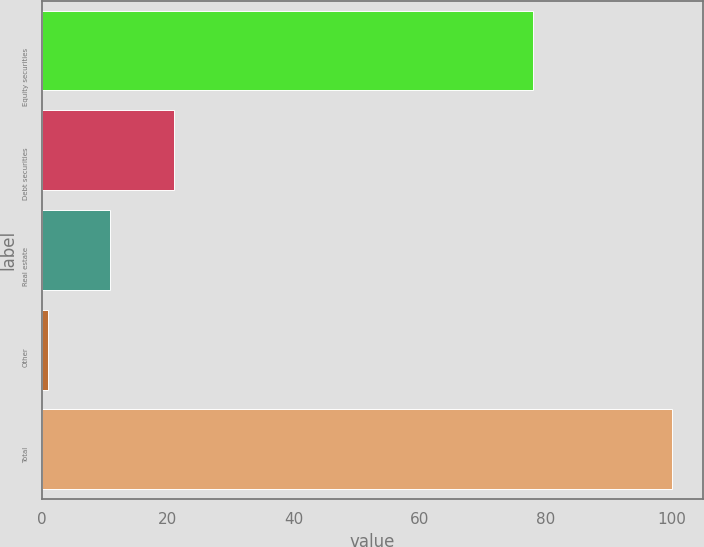<chart> <loc_0><loc_0><loc_500><loc_500><bar_chart><fcel>Equity securities<fcel>Debt securities<fcel>Real estate<fcel>Other<fcel>Total<nl><fcel>78<fcel>21<fcel>10.9<fcel>1<fcel>100<nl></chart> 